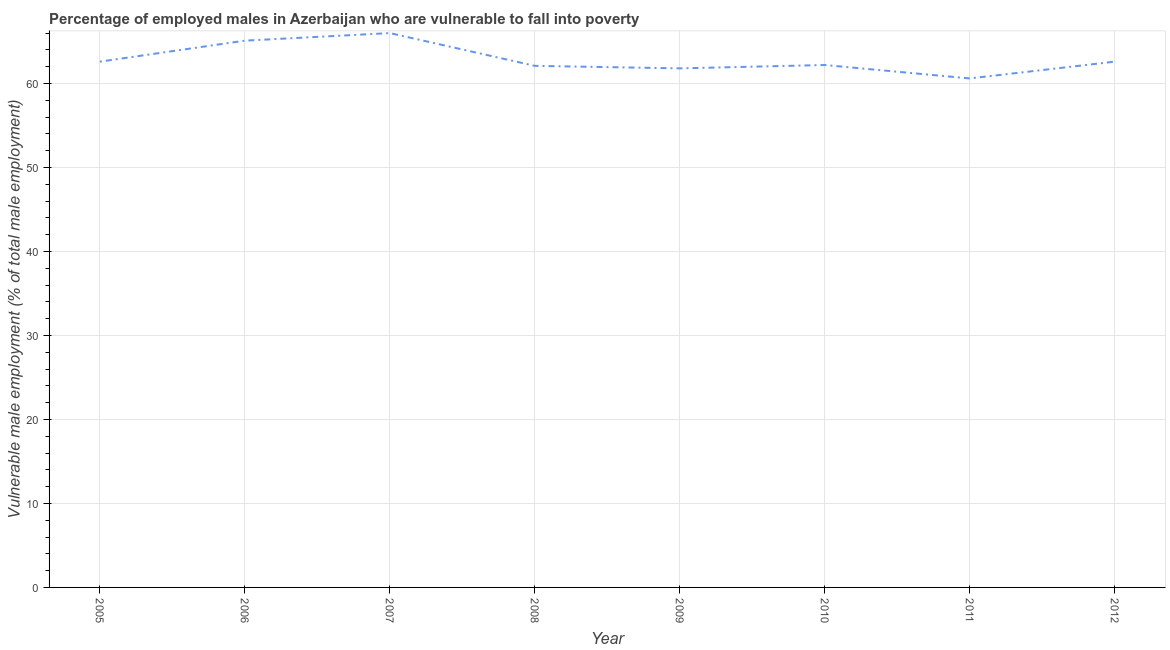What is the percentage of employed males who are vulnerable to fall into poverty in 2006?
Your response must be concise. 65.1. Across all years, what is the minimum percentage of employed males who are vulnerable to fall into poverty?
Keep it short and to the point. 60.6. In which year was the percentage of employed males who are vulnerable to fall into poverty maximum?
Make the answer very short. 2007. In which year was the percentage of employed males who are vulnerable to fall into poverty minimum?
Give a very brief answer. 2011. What is the sum of the percentage of employed males who are vulnerable to fall into poverty?
Your response must be concise. 503. What is the difference between the percentage of employed males who are vulnerable to fall into poverty in 2007 and 2008?
Your answer should be very brief. 3.9. What is the average percentage of employed males who are vulnerable to fall into poverty per year?
Ensure brevity in your answer.  62.87. What is the median percentage of employed males who are vulnerable to fall into poverty?
Ensure brevity in your answer.  62.4. Do a majority of the years between 2009 and 2008 (inclusive) have percentage of employed males who are vulnerable to fall into poverty greater than 40 %?
Your answer should be compact. No. What is the ratio of the percentage of employed males who are vulnerable to fall into poverty in 2008 to that in 2011?
Make the answer very short. 1.02. Is the percentage of employed males who are vulnerable to fall into poverty in 2007 less than that in 2008?
Ensure brevity in your answer.  No. Is the difference between the percentage of employed males who are vulnerable to fall into poverty in 2008 and 2011 greater than the difference between any two years?
Provide a short and direct response. No. What is the difference between the highest and the second highest percentage of employed males who are vulnerable to fall into poverty?
Your answer should be compact. 0.9. What is the difference between the highest and the lowest percentage of employed males who are vulnerable to fall into poverty?
Make the answer very short. 5.4. Does the percentage of employed males who are vulnerable to fall into poverty monotonically increase over the years?
Keep it short and to the point. No. How many lines are there?
Provide a succinct answer. 1. What is the difference between two consecutive major ticks on the Y-axis?
Offer a very short reply. 10. Does the graph contain any zero values?
Offer a terse response. No. What is the title of the graph?
Provide a succinct answer. Percentage of employed males in Azerbaijan who are vulnerable to fall into poverty. What is the label or title of the X-axis?
Offer a very short reply. Year. What is the label or title of the Y-axis?
Offer a very short reply. Vulnerable male employment (% of total male employment). What is the Vulnerable male employment (% of total male employment) of 2005?
Offer a terse response. 62.6. What is the Vulnerable male employment (% of total male employment) of 2006?
Ensure brevity in your answer.  65.1. What is the Vulnerable male employment (% of total male employment) of 2008?
Your answer should be compact. 62.1. What is the Vulnerable male employment (% of total male employment) in 2009?
Give a very brief answer. 61.8. What is the Vulnerable male employment (% of total male employment) in 2010?
Give a very brief answer. 62.2. What is the Vulnerable male employment (% of total male employment) of 2011?
Your answer should be very brief. 60.6. What is the Vulnerable male employment (% of total male employment) in 2012?
Offer a very short reply. 62.6. What is the difference between the Vulnerable male employment (% of total male employment) in 2005 and 2006?
Keep it short and to the point. -2.5. What is the difference between the Vulnerable male employment (% of total male employment) in 2005 and 2008?
Provide a succinct answer. 0.5. What is the difference between the Vulnerable male employment (% of total male employment) in 2005 and 2009?
Your response must be concise. 0.8. What is the difference between the Vulnerable male employment (% of total male employment) in 2005 and 2011?
Offer a very short reply. 2. What is the difference between the Vulnerable male employment (% of total male employment) in 2006 and 2007?
Your response must be concise. -0.9. What is the difference between the Vulnerable male employment (% of total male employment) in 2006 and 2008?
Make the answer very short. 3. What is the difference between the Vulnerable male employment (% of total male employment) in 2006 and 2009?
Your response must be concise. 3.3. What is the difference between the Vulnerable male employment (% of total male employment) in 2007 and 2008?
Offer a terse response. 3.9. What is the difference between the Vulnerable male employment (% of total male employment) in 2007 and 2009?
Ensure brevity in your answer.  4.2. What is the difference between the Vulnerable male employment (% of total male employment) in 2008 and 2010?
Keep it short and to the point. -0.1. What is the difference between the Vulnerable male employment (% of total male employment) in 2009 and 2010?
Make the answer very short. -0.4. What is the difference between the Vulnerable male employment (% of total male employment) in 2009 and 2012?
Ensure brevity in your answer.  -0.8. What is the ratio of the Vulnerable male employment (% of total male employment) in 2005 to that in 2007?
Keep it short and to the point. 0.95. What is the ratio of the Vulnerable male employment (% of total male employment) in 2005 to that in 2008?
Ensure brevity in your answer.  1.01. What is the ratio of the Vulnerable male employment (% of total male employment) in 2005 to that in 2009?
Offer a terse response. 1.01. What is the ratio of the Vulnerable male employment (% of total male employment) in 2005 to that in 2011?
Offer a terse response. 1.03. What is the ratio of the Vulnerable male employment (% of total male employment) in 2005 to that in 2012?
Your response must be concise. 1. What is the ratio of the Vulnerable male employment (% of total male employment) in 2006 to that in 2008?
Offer a terse response. 1.05. What is the ratio of the Vulnerable male employment (% of total male employment) in 2006 to that in 2009?
Provide a succinct answer. 1.05. What is the ratio of the Vulnerable male employment (% of total male employment) in 2006 to that in 2010?
Give a very brief answer. 1.05. What is the ratio of the Vulnerable male employment (% of total male employment) in 2006 to that in 2011?
Your answer should be compact. 1.07. What is the ratio of the Vulnerable male employment (% of total male employment) in 2006 to that in 2012?
Ensure brevity in your answer.  1.04. What is the ratio of the Vulnerable male employment (% of total male employment) in 2007 to that in 2008?
Make the answer very short. 1.06. What is the ratio of the Vulnerable male employment (% of total male employment) in 2007 to that in 2009?
Offer a very short reply. 1.07. What is the ratio of the Vulnerable male employment (% of total male employment) in 2007 to that in 2010?
Provide a short and direct response. 1.06. What is the ratio of the Vulnerable male employment (% of total male employment) in 2007 to that in 2011?
Offer a very short reply. 1.09. What is the ratio of the Vulnerable male employment (% of total male employment) in 2007 to that in 2012?
Ensure brevity in your answer.  1.05. What is the ratio of the Vulnerable male employment (% of total male employment) in 2008 to that in 2011?
Your answer should be very brief. 1.02. What is the ratio of the Vulnerable male employment (% of total male employment) in 2008 to that in 2012?
Ensure brevity in your answer.  0.99. What is the ratio of the Vulnerable male employment (% of total male employment) in 2009 to that in 2011?
Keep it short and to the point. 1.02. What is the ratio of the Vulnerable male employment (% of total male employment) in 2009 to that in 2012?
Make the answer very short. 0.99. What is the ratio of the Vulnerable male employment (% of total male employment) in 2010 to that in 2012?
Ensure brevity in your answer.  0.99. What is the ratio of the Vulnerable male employment (% of total male employment) in 2011 to that in 2012?
Keep it short and to the point. 0.97. 